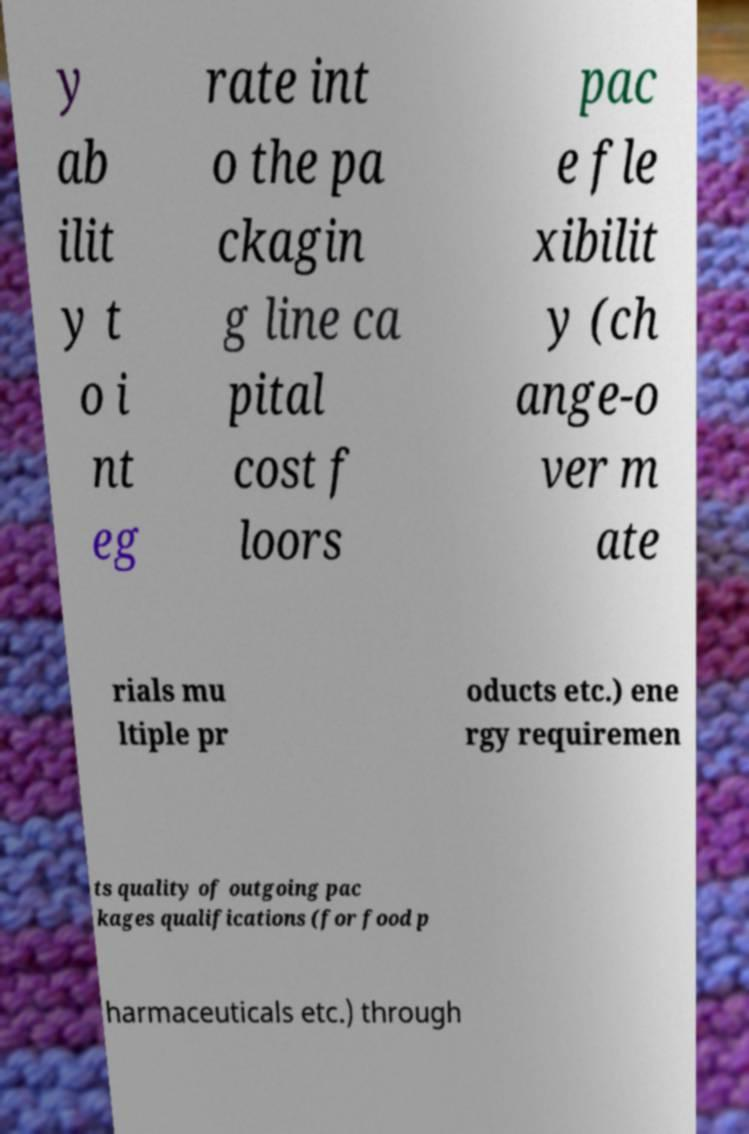Could you assist in decoding the text presented in this image and type it out clearly? y ab ilit y t o i nt eg rate int o the pa ckagin g line ca pital cost f loors pac e fle xibilit y (ch ange-o ver m ate rials mu ltiple pr oducts etc.) ene rgy requiremen ts quality of outgoing pac kages qualifications (for food p harmaceuticals etc.) through 